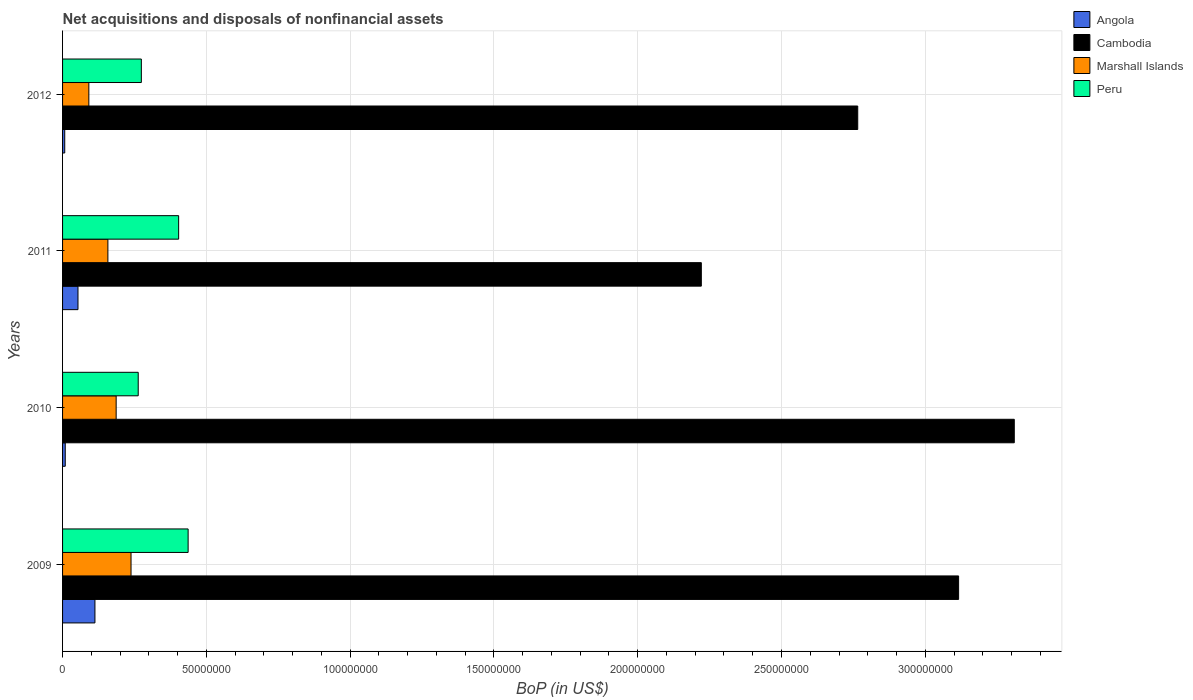How many different coloured bars are there?
Offer a very short reply. 4. How many groups of bars are there?
Make the answer very short. 4. Are the number of bars per tick equal to the number of legend labels?
Provide a succinct answer. Yes. Are the number of bars on each tick of the Y-axis equal?
Make the answer very short. Yes. How many bars are there on the 4th tick from the top?
Offer a very short reply. 4. How many bars are there on the 2nd tick from the bottom?
Offer a terse response. 4. What is the Balance of Payments in Marshall Islands in 2012?
Keep it short and to the point. 9.14e+06. Across all years, what is the maximum Balance of Payments in Peru?
Offer a very short reply. 4.37e+07. Across all years, what is the minimum Balance of Payments in Marshall Islands?
Provide a short and direct response. 9.14e+06. In which year was the Balance of Payments in Marshall Islands maximum?
Your answer should be compact. 2009. What is the total Balance of Payments in Angola in the graph?
Provide a short and direct response. 1.83e+07. What is the difference between the Balance of Payments in Marshall Islands in 2010 and that in 2011?
Provide a short and direct response. 2.88e+06. What is the difference between the Balance of Payments in Angola in 2011 and the Balance of Payments in Peru in 2012?
Provide a succinct answer. -2.20e+07. What is the average Balance of Payments in Angola per year?
Offer a very short reply. 4.58e+06. In the year 2009, what is the difference between the Balance of Payments in Angola and Balance of Payments in Marshall Islands?
Your response must be concise. -1.26e+07. What is the ratio of the Balance of Payments in Cambodia in 2009 to that in 2010?
Provide a succinct answer. 0.94. Is the Balance of Payments in Angola in 2010 less than that in 2011?
Keep it short and to the point. Yes. What is the difference between the highest and the second highest Balance of Payments in Angola?
Provide a short and direct response. 5.90e+06. What is the difference between the highest and the lowest Balance of Payments in Peru?
Make the answer very short. 1.74e+07. Is the sum of the Balance of Payments in Peru in 2009 and 2011 greater than the maximum Balance of Payments in Marshall Islands across all years?
Offer a terse response. Yes. What does the 4th bar from the top in 2010 represents?
Make the answer very short. Angola. What does the 2nd bar from the bottom in 2009 represents?
Your answer should be compact. Cambodia. Is it the case that in every year, the sum of the Balance of Payments in Marshall Islands and Balance of Payments in Angola is greater than the Balance of Payments in Cambodia?
Your response must be concise. No. How many bars are there?
Keep it short and to the point. 16. Does the graph contain any zero values?
Your answer should be compact. No. Does the graph contain grids?
Make the answer very short. Yes. Where does the legend appear in the graph?
Give a very brief answer. Top right. How many legend labels are there?
Provide a succinct answer. 4. What is the title of the graph?
Give a very brief answer. Net acquisitions and disposals of nonfinancial assets. Does "Slovenia" appear as one of the legend labels in the graph?
Keep it short and to the point. No. What is the label or title of the X-axis?
Keep it short and to the point. BoP (in US$). What is the label or title of the Y-axis?
Offer a very short reply. Years. What is the BoP (in US$) of Angola in 2009?
Offer a very short reply. 1.13e+07. What is the BoP (in US$) of Cambodia in 2009?
Your response must be concise. 3.12e+08. What is the BoP (in US$) of Marshall Islands in 2009?
Your answer should be compact. 2.38e+07. What is the BoP (in US$) in Peru in 2009?
Your answer should be compact. 4.37e+07. What is the BoP (in US$) of Angola in 2010?
Offer a very short reply. 9.34e+05. What is the BoP (in US$) of Cambodia in 2010?
Keep it short and to the point. 3.31e+08. What is the BoP (in US$) in Marshall Islands in 2010?
Provide a succinct answer. 1.86e+07. What is the BoP (in US$) of Peru in 2010?
Make the answer very short. 2.63e+07. What is the BoP (in US$) in Angola in 2011?
Keep it short and to the point. 5.36e+06. What is the BoP (in US$) in Cambodia in 2011?
Your answer should be compact. 2.22e+08. What is the BoP (in US$) in Marshall Islands in 2011?
Provide a succinct answer. 1.58e+07. What is the BoP (in US$) in Peru in 2011?
Make the answer very short. 4.04e+07. What is the BoP (in US$) in Angola in 2012?
Your answer should be compact. 7.54e+05. What is the BoP (in US$) in Cambodia in 2012?
Give a very brief answer. 2.77e+08. What is the BoP (in US$) in Marshall Islands in 2012?
Keep it short and to the point. 9.14e+06. What is the BoP (in US$) in Peru in 2012?
Offer a terse response. 2.74e+07. Across all years, what is the maximum BoP (in US$) in Angola?
Keep it short and to the point. 1.13e+07. Across all years, what is the maximum BoP (in US$) of Cambodia?
Offer a very short reply. 3.31e+08. Across all years, what is the maximum BoP (in US$) of Marshall Islands?
Make the answer very short. 2.38e+07. Across all years, what is the maximum BoP (in US$) in Peru?
Offer a very short reply. 4.37e+07. Across all years, what is the minimum BoP (in US$) in Angola?
Ensure brevity in your answer.  7.54e+05. Across all years, what is the minimum BoP (in US$) in Cambodia?
Your answer should be compact. 2.22e+08. Across all years, what is the minimum BoP (in US$) of Marshall Islands?
Your response must be concise. 9.14e+06. Across all years, what is the minimum BoP (in US$) of Peru?
Ensure brevity in your answer.  2.63e+07. What is the total BoP (in US$) in Angola in the graph?
Your answer should be very brief. 1.83e+07. What is the total BoP (in US$) in Cambodia in the graph?
Your response must be concise. 1.14e+09. What is the total BoP (in US$) of Marshall Islands in the graph?
Your response must be concise. 6.73e+07. What is the total BoP (in US$) of Peru in the graph?
Provide a succinct answer. 1.38e+08. What is the difference between the BoP (in US$) of Angola in 2009 and that in 2010?
Your answer should be compact. 1.03e+07. What is the difference between the BoP (in US$) of Cambodia in 2009 and that in 2010?
Your answer should be compact. -1.94e+07. What is the difference between the BoP (in US$) in Marshall Islands in 2009 and that in 2010?
Offer a terse response. 5.17e+06. What is the difference between the BoP (in US$) of Peru in 2009 and that in 2010?
Offer a very short reply. 1.74e+07. What is the difference between the BoP (in US$) in Angola in 2009 and that in 2011?
Ensure brevity in your answer.  5.90e+06. What is the difference between the BoP (in US$) of Cambodia in 2009 and that in 2011?
Provide a short and direct response. 8.95e+07. What is the difference between the BoP (in US$) of Marshall Islands in 2009 and that in 2011?
Provide a succinct answer. 8.05e+06. What is the difference between the BoP (in US$) in Peru in 2009 and that in 2011?
Offer a very short reply. 3.30e+06. What is the difference between the BoP (in US$) of Angola in 2009 and that in 2012?
Your response must be concise. 1.05e+07. What is the difference between the BoP (in US$) of Cambodia in 2009 and that in 2012?
Provide a succinct answer. 3.51e+07. What is the difference between the BoP (in US$) in Marshall Islands in 2009 and that in 2012?
Ensure brevity in your answer.  1.47e+07. What is the difference between the BoP (in US$) in Peru in 2009 and that in 2012?
Your answer should be compact. 1.63e+07. What is the difference between the BoP (in US$) of Angola in 2010 and that in 2011?
Make the answer very short. -4.43e+06. What is the difference between the BoP (in US$) of Cambodia in 2010 and that in 2011?
Offer a very short reply. 1.09e+08. What is the difference between the BoP (in US$) in Marshall Islands in 2010 and that in 2011?
Provide a short and direct response. 2.88e+06. What is the difference between the BoP (in US$) of Peru in 2010 and that in 2011?
Ensure brevity in your answer.  -1.41e+07. What is the difference between the BoP (in US$) of Angola in 2010 and that in 2012?
Keep it short and to the point. 1.80e+05. What is the difference between the BoP (in US$) of Cambodia in 2010 and that in 2012?
Provide a short and direct response. 5.44e+07. What is the difference between the BoP (in US$) in Marshall Islands in 2010 and that in 2012?
Make the answer very short. 9.50e+06. What is the difference between the BoP (in US$) in Peru in 2010 and that in 2012?
Make the answer very short. -1.09e+06. What is the difference between the BoP (in US$) in Angola in 2011 and that in 2012?
Your response must be concise. 4.61e+06. What is the difference between the BoP (in US$) of Cambodia in 2011 and that in 2012?
Ensure brevity in your answer.  -5.44e+07. What is the difference between the BoP (in US$) in Marshall Islands in 2011 and that in 2012?
Provide a succinct answer. 6.62e+06. What is the difference between the BoP (in US$) of Peru in 2011 and that in 2012?
Offer a very short reply. 1.30e+07. What is the difference between the BoP (in US$) in Angola in 2009 and the BoP (in US$) in Cambodia in 2010?
Provide a short and direct response. -3.20e+08. What is the difference between the BoP (in US$) of Angola in 2009 and the BoP (in US$) of Marshall Islands in 2010?
Your response must be concise. -7.38e+06. What is the difference between the BoP (in US$) of Angola in 2009 and the BoP (in US$) of Peru in 2010?
Make the answer very short. -1.50e+07. What is the difference between the BoP (in US$) of Cambodia in 2009 and the BoP (in US$) of Marshall Islands in 2010?
Your answer should be compact. 2.93e+08. What is the difference between the BoP (in US$) of Cambodia in 2009 and the BoP (in US$) of Peru in 2010?
Provide a short and direct response. 2.85e+08. What is the difference between the BoP (in US$) in Marshall Islands in 2009 and the BoP (in US$) in Peru in 2010?
Your answer should be compact. -2.50e+06. What is the difference between the BoP (in US$) in Angola in 2009 and the BoP (in US$) in Cambodia in 2011?
Make the answer very short. -2.11e+08. What is the difference between the BoP (in US$) in Angola in 2009 and the BoP (in US$) in Marshall Islands in 2011?
Your response must be concise. -4.50e+06. What is the difference between the BoP (in US$) of Angola in 2009 and the BoP (in US$) of Peru in 2011?
Give a very brief answer. -2.91e+07. What is the difference between the BoP (in US$) in Cambodia in 2009 and the BoP (in US$) in Marshall Islands in 2011?
Your answer should be very brief. 2.96e+08. What is the difference between the BoP (in US$) in Cambodia in 2009 and the BoP (in US$) in Peru in 2011?
Make the answer very short. 2.71e+08. What is the difference between the BoP (in US$) of Marshall Islands in 2009 and the BoP (in US$) of Peru in 2011?
Provide a succinct answer. -1.66e+07. What is the difference between the BoP (in US$) in Angola in 2009 and the BoP (in US$) in Cambodia in 2012?
Ensure brevity in your answer.  -2.65e+08. What is the difference between the BoP (in US$) in Angola in 2009 and the BoP (in US$) in Marshall Islands in 2012?
Your answer should be compact. 2.12e+06. What is the difference between the BoP (in US$) in Angola in 2009 and the BoP (in US$) in Peru in 2012?
Provide a short and direct response. -1.61e+07. What is the difference between the BoP (in US$) in Cambodia in 2009 and the BoP (in US$) in Marshall Islands in 2012?
Offer a terse response. 3.02e+08. What is the difference between the BoP (in US$) of Cambodia in 2009 and the BoP (in US$) of Peru in 2012?
Your answer should be compact. 2.84e+08. What is the difference between the BoP (in US$) in Marshall Islands in 2009 and the BoP (in US$) in Peru in 2012?
Offer a very short reply. -3.58e+06. What is the difference between the BoP (in US$) of Angola in 2010 and the BoP (in US$) of Cambodia in 2011?
Your answer should be very brief. -2.21e+08. What is the difference between the BoP (in US$) in Angola in 2010 and the BoP (in US$) in Marshall Islands in 2011?
Give a very brief answer. -1.48e+07. What is the difference between the BoP (in US$) of Angola in 2010 and the BoP (in US$) of Peru in 2011?
Your answer should be very brief. -3.94e+07. What is the difference between the BoP (in US$) of Cambodia in 2010 and the BoP (in US$) of Marshall Islands in 2011?
Offer a very short reply. 3.15e+08. What is the difference between the BoP (in US$) of Cambodia in 2010 and the BoP (in US$) of Peru in 2011?
Ensure brevity in your answer.  2.91e+08. What is the difference between the BoP (in US$) of Marshall Islands in 2010 and the BoP (in US$) of Peru in 2011?
Offer a terse response. -2.17e+07. What is the difference between the BoP (in US$) in Angola in 2010 and the BoP (in US$) in Cambodia in 2012?
Make the answer very short. -2.76e+08. What is the difference between the BoP (in US$) in Angola in 2010 and the BoP (in US$) in Marshall Islands in 2012?
Your response must be concise. -8.21e+06. What is the difference between the BoP (in US$) of Angola in 2010 and the BoP (in US$) of Peru in 2012?
Ensure brevity in your answer.  -2.65e+07. What is the difference between the BoP (in US$) in Cambodia in 2010 and the BoP (in US$) in Marshall Islands in 2012?
Give a very brief answer. 3.22e+08. What is the difference between the BoP (in US$) of Cambodia in 2010 and the BoP (in US$) of Peru in 2012?
Make the answer very short. 3.04e+08. What is the difference between the BoP (in US$) in Marshall Islands in 2010 and the BoP (in US$) in Peru in 2012?
Make the answer very short. -8.76e+06. What is the difference between the BoP (in US$) of Angola in 2011 and the BoP (in US$) of Cambodia in 2012?
Offer a very short reply. -2.71e+08. What is the difference between the BoP (in US$) of Angola in 2011 and the BoP (in US$) of Marshall Islands in 2012?
Your answer should be very brief. -3.78e+06. What is the difference between the BoP (in US$) of Angola in 2011 and the BoP (in US$) of Peru in 2012?
Ensure brevity in your answer.  -2.20e+07. What is the difference between the BoP (in US$) in Cambodia in 2011 and the BoP (in US$) in Marshall Islands in 2012?
Offer a very short reply. 2.13e+08. What is the difference between the BoP (in US$) of Cambodia in 2011 and the BoP (in US$) of Peru in 2012?
Make the answer very short. 1.95e+08. What is the difference between the BoP (in US$) in Marshall Islands in 2011 and the BoP (in US$) in Peru in 2012?
Your answer should be compact. -1.16e+07. What is the average BoP (in US$) of Angola per year?
Offer a terse response. 4.58e+06. What is the average BoP (in US$) of Cambodia per year?
Provide a succinct answer. 2.85e+08. What is the average BoP (in US$) in Marshall Islands per year?
Your response must be concise. 1.68e+07. What is the average BoP (in US$) in Peru per year?
Offer a terse response. 3.44e+07. In the year 2009, what is the difference between the BoP (in US$) of Angola and BoP (in US$) of Cambodia?
Your response must be concise. -3.00e+08. In the year 2009, what is the difference between the BoP (in US$) in Angola and BoP (in US$) in Marshall Islands?
Offer a very short reply. -1.26e+07. In the year 2009, what is the difference between the BoP (in US$) in Angola and BoP (in US$) in Peru?
Your response must be concise. -3.24e+07. In the year 2009, what is the difference between the BoP (in US$) in Cambodia and BoP (in US$) in Marshall Islands?
Give a very brief answer. 2.88e+08. In the year 2009, what is the difference between the BoP (in US$) in Cambodia and BoP (in US$) in Peru?
Your answer should be very brief. 2.68e+08. In the year 2009, what is the difference between the BoP (in US$) of Marshall Islands and BoP (in US$) of Peru?
Ensure brevity in your answer.  -1.99e+07. In the year 2010, what is the difference between the BoP (in US$) in Angola and BoP (in US$) in Cambodia?
Your answer should be very brief. -3.30e+08. In the year 2010, what is the difference between the BoP (in US$) in Angola and BoP (in US$) in Marshall Islands?
Give a very brief answer. -1.77e+07. In the year 2010, what is the difference between the BoP (in US$) of Angola and BoP (in US$) of Peru?
Provide a short and direct response. -2.54e+07. In the year 2010, what is the difference between the BoP (in US$) of Cambodia and BoP (in US$) of Marshall Islands?
Your answer should be compact. 3.12e+08. In the year 2010, what is the difference between the BoP (in US$) of Cambodia and BoP (in US$) of Peru?
Your answer should be very brief. 3.05e+08. In the year 2010, what is the difference between the BoP (in US$) of Marshall Islands and BoP (in US$) of Peru?
Give a very brief answer. -7.67e+06. In the year 2011, what is the difference between the BoP (in US$) of Angola and BoP (in US$) of Cambodia?
Offer a very short reply. -2.17e+08. In the year 2011, what is the difference between the BoP (in US$) of Angola and BoP (in US$) of Marshall Islands?
Provide a succinct answer. -1.04e+07. In the year 2011, what is the difference between the BoP (in US$) in Angola and BoP (in US$) in Peru?
Offer a terse response. -3.50e+07. In the year 2011, what is the difference between the BoP (in US$) of Cambodia and BoP (in US$) of Marshall Islands?
Provide a short and direct response. 2.06e+08. In the year 2011, what is the difference between the BoP (in US$) of Cambodia and BoP (in US$) of Peru?
Provide a succinct answer. 1.82e+08. In the year 2011, what is the difference between the BoP (in US$) of Marshall Islands and BoP (in US$) of Peru?
Give a very brief answer. -2.46e+07. In the year 2012, what is the difference between the BoP (in US$) in Angola and BoP (in US$) in Cambodia?
Give a very brief answer. -2.76e+08. In the year 2012, what is the difference between the BoP (in US$) in Angola and BoP (in US$) in Marshall Islands?
Make the answer very short. -8.39e+06. In the year 2012, what is the difference between the BoP (in US$) in Angola and BoP (in US$) in Peru?
Offer a terse response. -2.66e+07. In the year 2012, what is the difference between the BoP (in US$) of Cambodia and BoP (in US$) of Marshall Islands?
Your answer should be compact. 2.67e+08. In the year 2012, what is the difference between the BoP (in US$) of Cambodia and BoP (in US$) of Peru?
Provide a short and direct response. 2.49e+08. In the year 2012, what is the difference between the BoP (in US$) in Marshall Islands and BoP (in US$) in Peru?
Your answer should be compact. -1.83e+07. What is the ratio of the BoP (in US$) in Angola in 2009 to that in 2010?
Keep it short and to the point. 12.05. What is the ratio of the BoP (in US$) of Cambodia in 2009 to that in 2010?
Your answer should be compact. 0.94. What is the ratio of the BoP (in US$) in Marshall Islands in 2009 to that in 2010?
Keep it short and to the point. 1.28. What is the ratio of the BoP (in US$) of Peru in 2009 to that in 2010?
Your response must be concise. 1.66. What is the ratio of the BoP (in US$) in Angola in 2009 to that in 2011?
Your answer should be very brief. 2.1. What is the ratio of the BoP (in US$) in Cambodia in 2009 to that in 2011?
Your answer should be compact. 1.4. What is the ratio of the BoP (in US$) in Marshall Islands in 2009 to that in 2011?
Your answer should be very brief. 1.51. What is the ratio of the BoP (in US$) in Peru in 2009 to that in 2011?
Provide a short and direct response. 1.08. What is the ratio of the BoP (in US$) in Angola in 2009 to that in 2012?
Your answer should be compact. 14.93. What is the ratio of the BoP (in US$) in Cambodia in 2009 to that in 2012?
Keep it short and to the point. 1.13. What is the ratio of the BoP (in US$) in Marshall Islands in 2009 to that in 2012?
Offer a very short reply. 2.6. What is the ratio of the BoP (in US$) in Peru in 2009 to that in 2012?
Offer a very short reply. 1.59. What is the ratio of the BoP (in US$) of Angola in 2010 to that in 2011?
Your answer should be compact. 0.17. What is the ratio of the BoP (in US$) in Cambodia in 2010 to that in 2011?
Provide a short and direct response. 1.49. What is the ratio of the BoP (in US$) in Marshall Islands in 2010 to that in 2011?
Your response must be concise. 1.18. What is the ratio of the BoP (in US$) of Peru in 2010 to that in 2011?
Provide a short and direct response. 0.65. What is the ratio of the BoP (in US$) of Angola in 2010 to that in 2012?
Provide a short and direct response. 1.24. What is the ratio of the BoP (in US$) in Cambodia in 2010 to that in 2012?
Make the answer very short. 1.2. What is the ratio of the BoP (in US$) of Marshall Islands in 2010 to that in 2012?
Your response must be concise. 2.04. What is the ratio of the BoP (in US$) in Peru in 2010 to that in 2012?
Offer a very short reply. 0.96. What is the ratio of the BoP (in US$) in Angola in 2011 to that in 2012?
Keep it short and to the point. 7.11. What is the ratio of the BoP (in US$) of Cambodia in 2011 to that in 2012?
Make the answer very short. 0.8. What is the ratio of the BoP (in US$) of Marshall Islands in 2011 to that in 2012?
Your answer should be compact. 1.72. What is the ratio of the BoP (in US$) of Peru in 2011 to that in 2012?
Offer a terse response. 1.47. What is the difference between the highest and the second highest BoP (in US$) of Angola?
Keep it short and to the point. 5.90e+06. What is the difference between the highest and the second highest BoP (in US$) of Cambodia?
Your answer should be compact. 1.94e+07. What is the difference between the highest and the second highest BoP (in US$) of Marshall Islands?
Provide a short and direct response. 5.17e+06. What is the difference between the highest and the second highest BoP (in US$) in Peru?
Give a very brief answer. 3.30e+06. What is the difference between the highest and the lowest BoP (in US$) of Angola?
Provide a short and direct response. 1.05e+07. What is the difference between the highest and the lowest BoP (in US$) in Cambodia?
Offer a very short reply. 1.09e+08. What is the difference between the highest and the lowest BoP (in US$) in Marshall Islands?
Your answer should be compact. 1.47e+07. What is the difference between the highest and the lowest BoP (in US$) in Peru?
Offer a very short reply. 1.74e+07. 